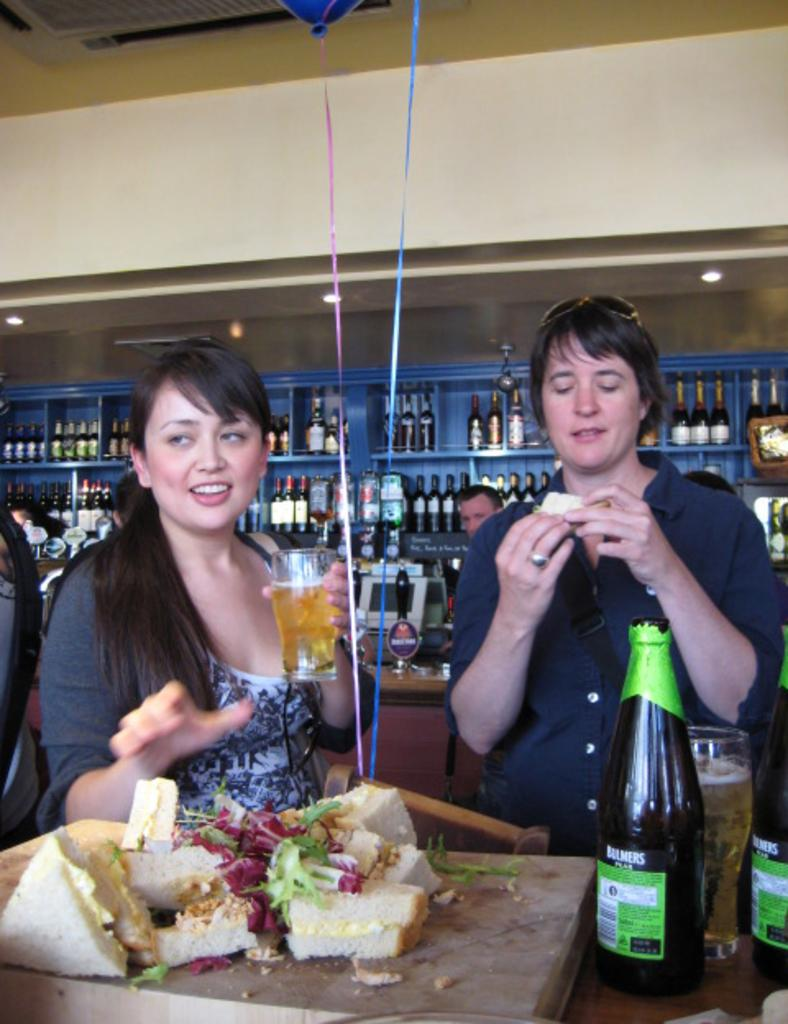Provide a one-sentence caption for the provided image. A pair of large liquor bottles are labeled with the Bulmers brand name. 